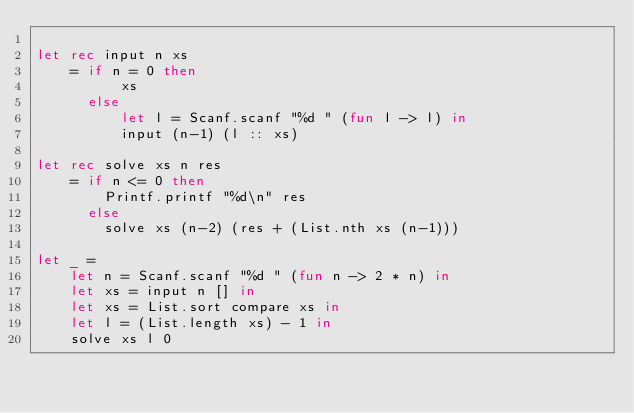<code> <loc_0><loc_0><loc_500><loc_500><_OCaml_>
let rec input n xs
    = if n = 0 then
          xs
      else
          let l = Scanf.scanf "%d " (fun l -> l) in
          input (n-1) (l :: xs)

let rec solve xs n res
    = if n <= 0 then
        Printf.printf "%d\n" res
      else
        solve xs (n-2) (res + (List.nth xs (n-1)))

let _ =
    let n = Scanf.scanf "%d " (fun n -> 2 * n) in
    let xs = input n [] in
    let xs = List.sort compare xs in
    let l = (List.length xs) - 1 in
    solve xs l 0
</code> 